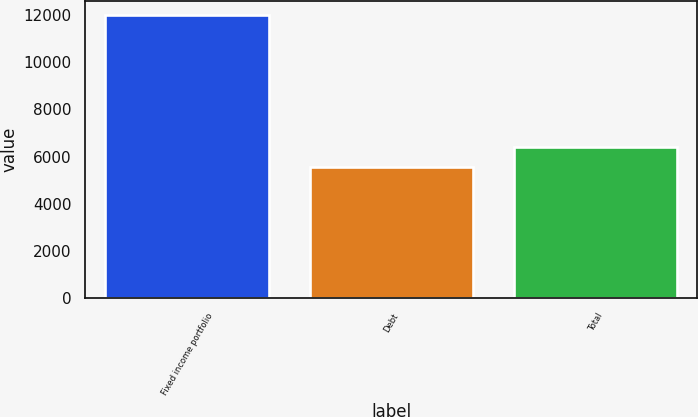Convert chart to OTSL. <chart><loc_0><loc_0><loc_500><loc_500><bar_chart><fcel>Fixed income portfolio<fcel>Debt<fcel>Total<nl><fcel>11977<fcel>5567<fcel>6410<nl></chart> 